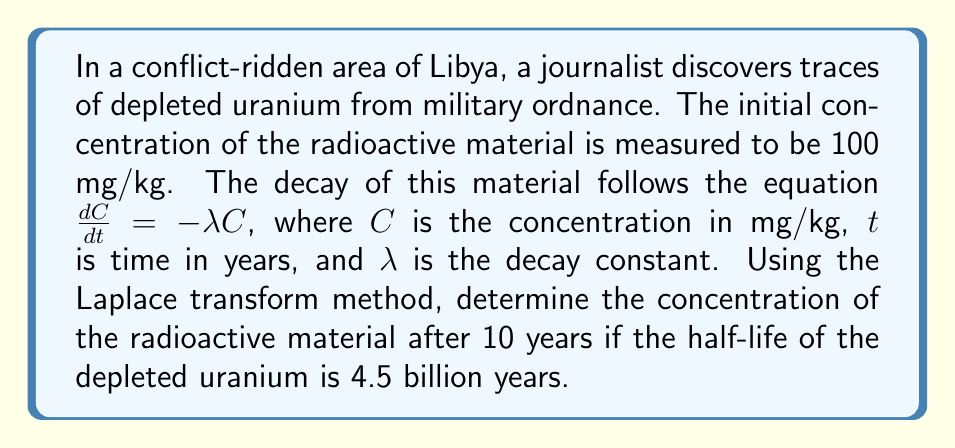Provide a solution to this math problem. Let's approach this problem step-by-step using the Laplace transform method:

1) The differential equation describing the decay is:

   $$\frac{dC}{dt} = -\lambda C$$

   with initial condition $C(0) = 100$ mg/kg.

2) Taking the Laplace transform of both sides:

   $$\mathcal{L}\left\{\frac{dC}{dt}\right\} = \mathcal{L}\{-\lambda C\}$$

3) Using the property of Laplace transform for derivatives:

   $$s\mathcal{L}\{C\} - C(0) = -\lambda \mathcal{L}\{C\}$$

4) Let $\mathcal{L}\{C\} = F(s)$. Substituting and rearranging:

   $$sF(s) - 100 = -\lambda F(s)$$
   $$(s + \lambda)F(s) = 100$$
   $$F(s) = \frac{100}{s + \lambda}$$

5) The inverse Laplace transform of this is:

   $$C(t) = 100e^{-\lambda t}$$

6) We need to find $\lambda$. Given the half-life $t_{1/2} = 4.5 \times 10^9$ years:

   $$\frac{1}{2} = e^{-\lambda t_{1/2}}$$
   $$\ln(1/2) = -\lambda (4.5 \times 10^9)$$
   $$\lambda = \frac{\ln(2)}{4.5 \times 10^9} \approx 1.54 \times 10^{-10} \text{ year}^{-1}$$

7) Now we can calculate the concentration after 10 years:

   $$C(10) = 100e^{-(1.54 \times 10^{-10})(10)}$$
Answer: $C(10) \approx 99.9999999846$ mg/kg 